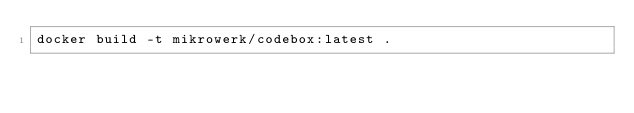Convert code to text. <code><loc_0><loc_0><loc_500><loc_500><_Bash_>docker build -t mikrowerk/codebox:latest .</code> 